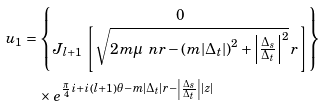Convert formula to latex. <formula><loc_0><loc_0><loc_500><loc_500>u _ { 1 } & = \begin{Bmatrix} 0 \\ J _ { l + 1 } \, \left [ \sqrt { 2 m \mu _ { \ } n r - \left ( m | \Delta _ { t } | \right ) ^ { 2 } + \left | \frac { \Delta _ { s } } { \Delta _ { t } } \right | ^ { 2 } } \, r \right ] \end{Bmatrix} \\ & \quad \times e ^ { \frac { \pi } { 4 } i + i \left ( l + 1 \right ) \theta - m | \Delta _ { t } | r - \left | \frac { \Delta _ { s } } { \Delta _ { t } } \right | | z | }</formula> 